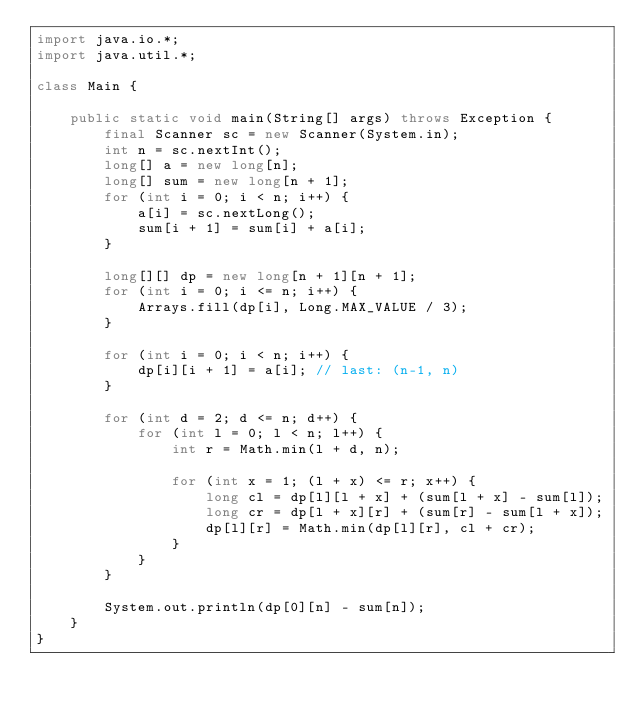Convert code to text. <code><loc_0><loc_0><loc_500><loc_500><_Java_>import java.io.*;
import java.util.*;

class Main {

	public static void main(String[] args) throws Exception {
		final Scanner sc = new Scanner(System.in);
		int n = sc.nextInt();
		long[] a = new long[n];
		long[] sum = new long[n + 1];
		for (int i = 0; i < n; i++) {
			a[i] = sc.nextLong();
			sum[i + 1] = sum[i] + a[i];
		}

		long[][] dp = new long[n + 1][n + 1];
		for (int i = 0; i <= n; i++) {
			Arrays.fill(dp[i], Long.MAX_VALUE / 3);
		}

		for (int i = 0; i < n; i++) {
			dp[i][i + 1] = a[i]; // last: (n-1, n)
		}

		for (int d = 2; d <= n; d++) {
			for (int l = 0; l < n; l++) {
				int r = Math.min(l + d, n);

				for (int x = 1; (l + x) <= r; x++) {
					long cl = dp[l][l + x] + (sum[l + x] - sum[l]);
					long cr = dp[l + x][r] + (sum[r] - sum[l + x]);
					dp[l][r] = Math.min(dp[l][r], cl + cr);
				}
			}
		}

		System.out.println(dp[0][n] - sum[n]);
	}
}
</code> 